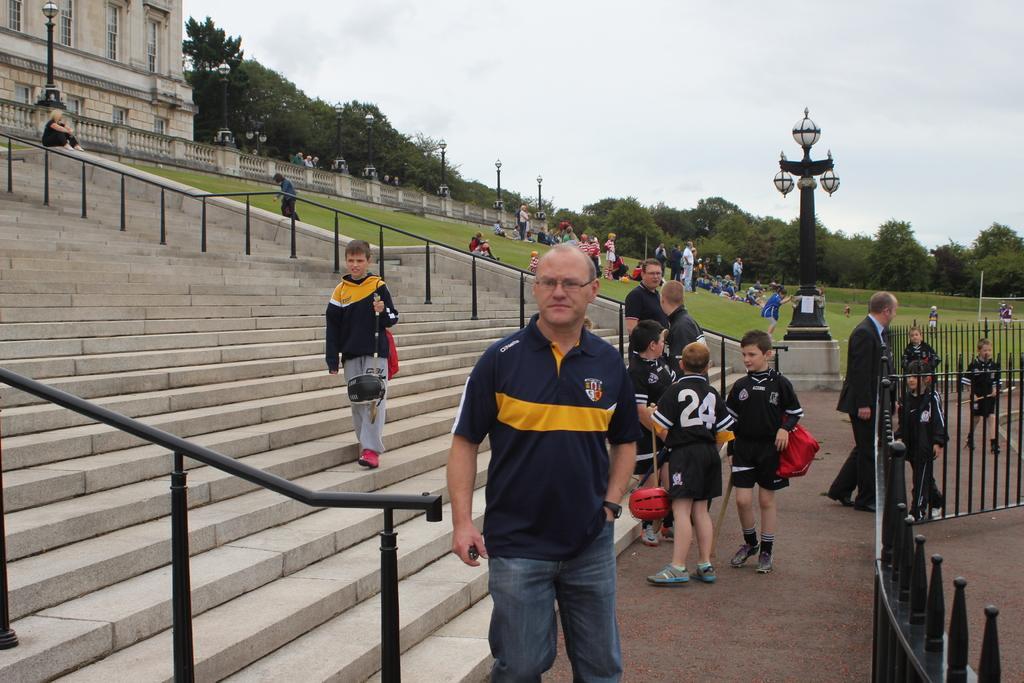Can you describe this image briefly? In this picture I can observe some people in the middle of the picture. There are men and children. On the right side I can observe a pole to which lights are fixed. In the background I can observe trees and sky. 